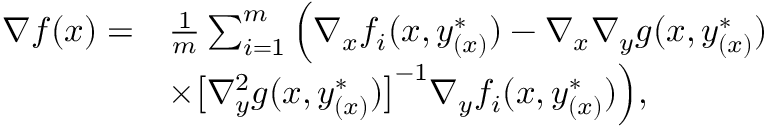Convert formula to latex. <formula><loc_0><loc_0><loc_500><loc_500>\begin{array} { r l } { \nabla f ( x ) = } & { \frac { 1 } { m } \sum _ { i = 1 } ^ { m } \left ( \nabla _ { x } f _ { i } ( x , y _ { ( x ) } ^ { * } ) - \nabla _ { x } \nabla _ { y } g ( x , y _ { ( x ) } ^ { * } ) } \\ & { \times \left [ \nabla _ { y } ^ { 2 } g ( x , y _ { ( x ) } ^ { * } ) \right ] ^ { - 1 } \nabla _ { y } f _ { i } ( x , y _ { ( x ) } ^ { * } ) \right ) , } \end{array}</formula> 